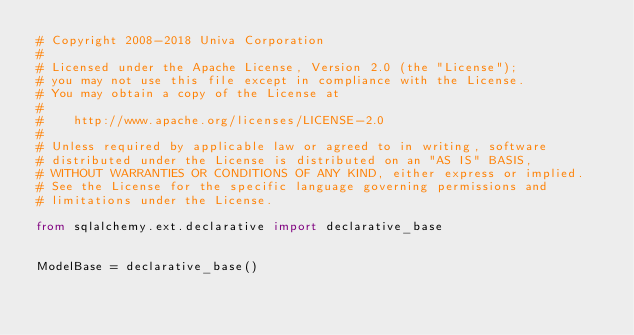<code> <loc_0><loc_0><loc_500><loc_500><_Python_># Copyright 2008-2018 Univa Corporation
#
# Licensed under the Apache License, Version 2.0 (the "License");
# you may not use this file except in compliance with the License.
# You may obtain a copy of the License at
#
#    http://www.apache.org/licenses/LICENSE-2.0
#
# Unless required by applicable law or agreed to in writing, software
# distributed under the License is distributed on an "AS IS" BASIS,
# WITHOUT WARRANTIES OR CONDITIONS OF ANY KIND, either express or implied.
# See the License for the specific language governing permissions and
# limitations under the License.

from sqlalchemy.ext.declarative import declarative_base


ModelBase = declarative_base()
</code> 